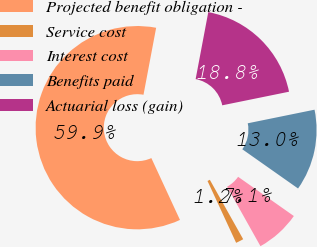<chart> <loc_0><loc_0><loc_500><loc_500><pie_chart><fcel>Projected benefit obligation -<fcel>Service cost<fcel>Interest cost<fcel>Benefits paid<fcel>Actuarial loss (gain)<nl><fcel>59.87%<fcel>1.24%<fcel>7.1%<fcel>12.96%<fcel>18.83%<nl></chart> 